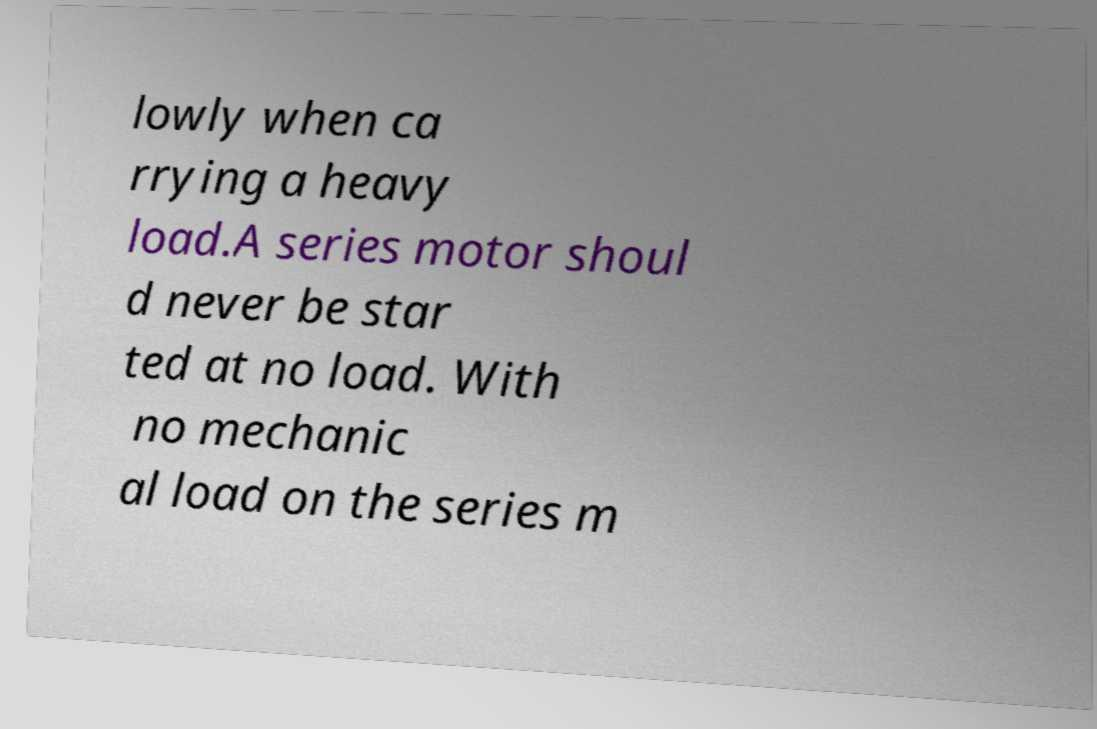Could you extract and type out the text from this image? lowly when ca rrying a heavy load.A series motor shoul d never be star ted at no load. With no mechanic al load on the series m 